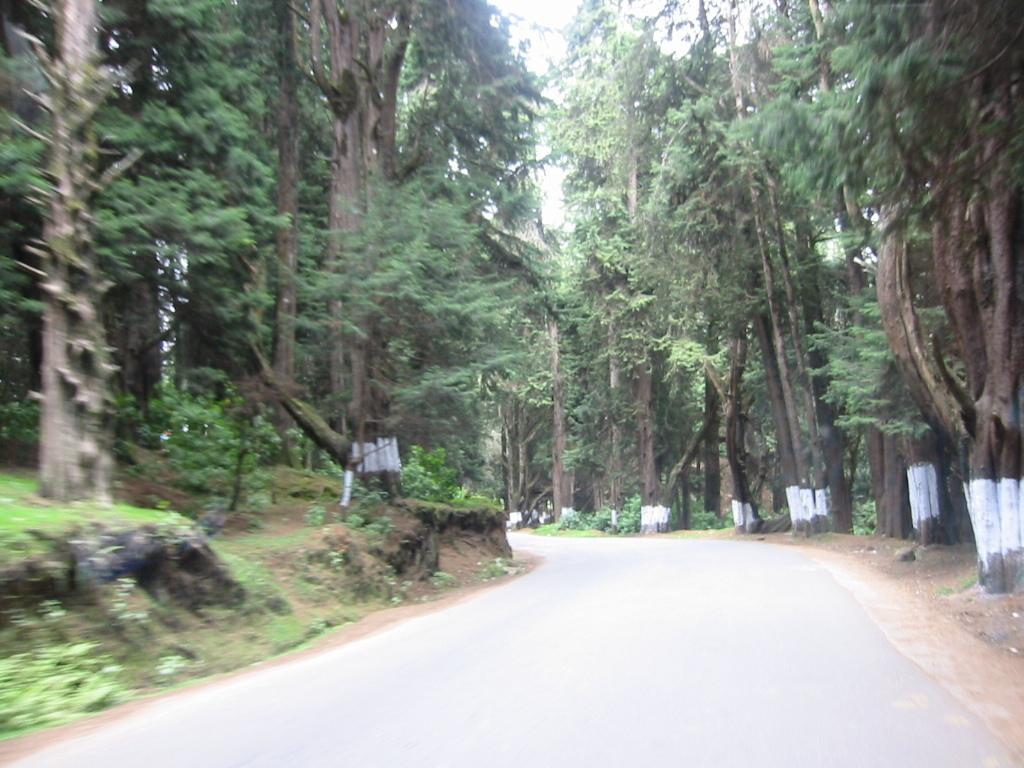Describe this image in one or two sentences. In this picture I can see many trees, plants and grass. At the bottom there is a road. At the top I can see the sky. 